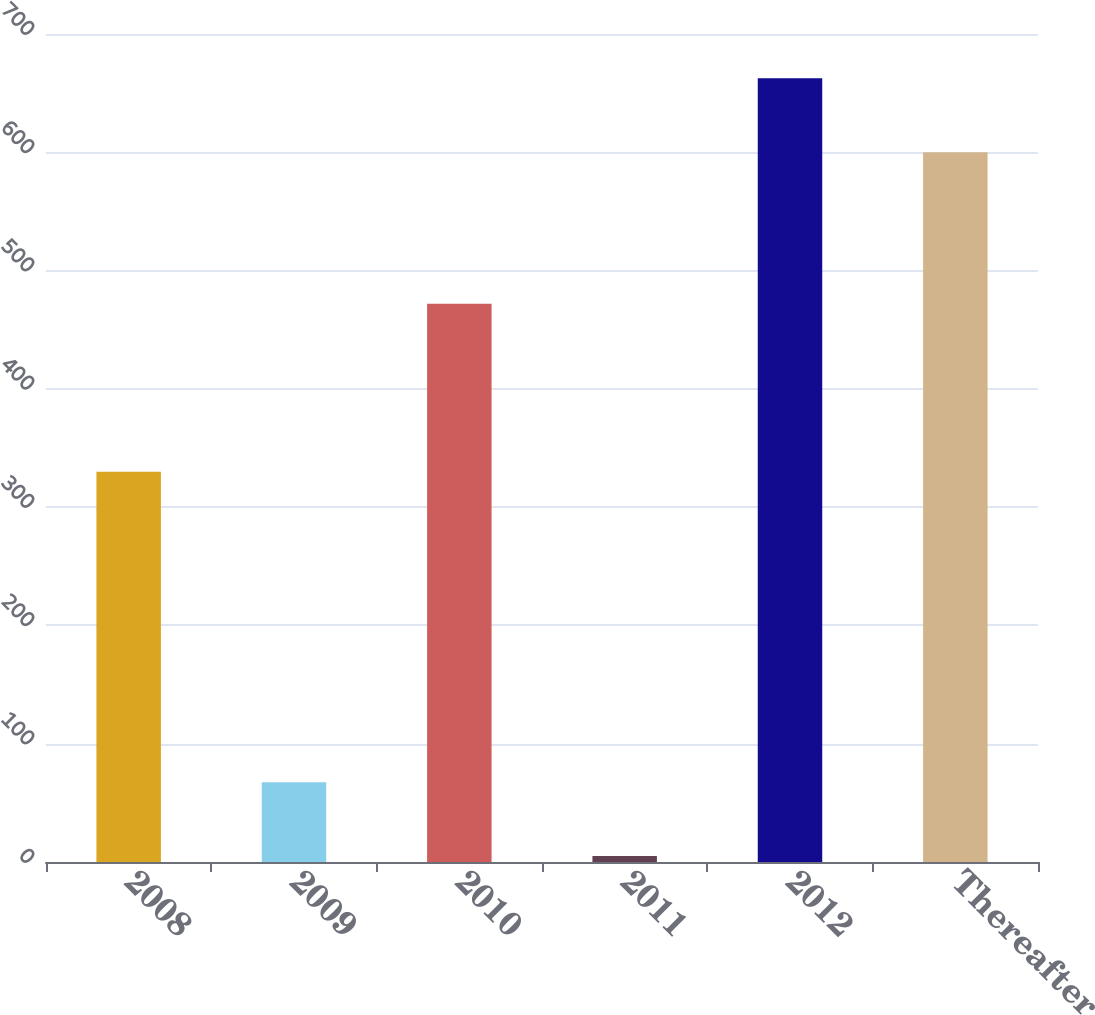<chart> <loc_0><loc_0><loc_500><loc_500><bar_chart><fcel>2008<fcel>2009<fcel>2010<fcel>2011<fcel>2012<fcel>Thereafter<nl><fcel>330<fcel>67.5<fcel>472<fcel>5<fcel>662.5<fcel>600<nl></chart> 